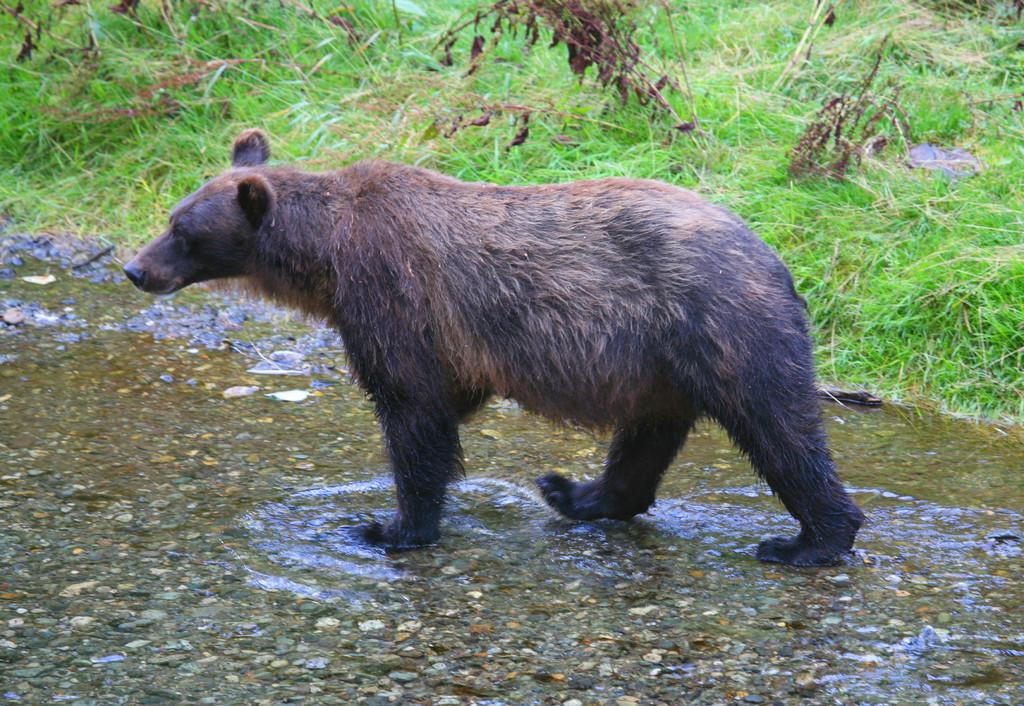What animal is present in the image? There is a bear in the image. What colors can be seen on the bear? The bear is brown and black in color. What is the bear doing in the image? The bear is walking in the water. What type of vegetation is visible in the background of the image? There is grass and plants in the background of the image. What color is the grass? The grass is green in color. What type of iron is being used by the bear in the image? There is no iron present in the image; it features a bear walking in the water. How does the bear stretch its limbs while walking in the water? The image does not show the bear stretching its limbs; it only shows the bear walking in the water. 